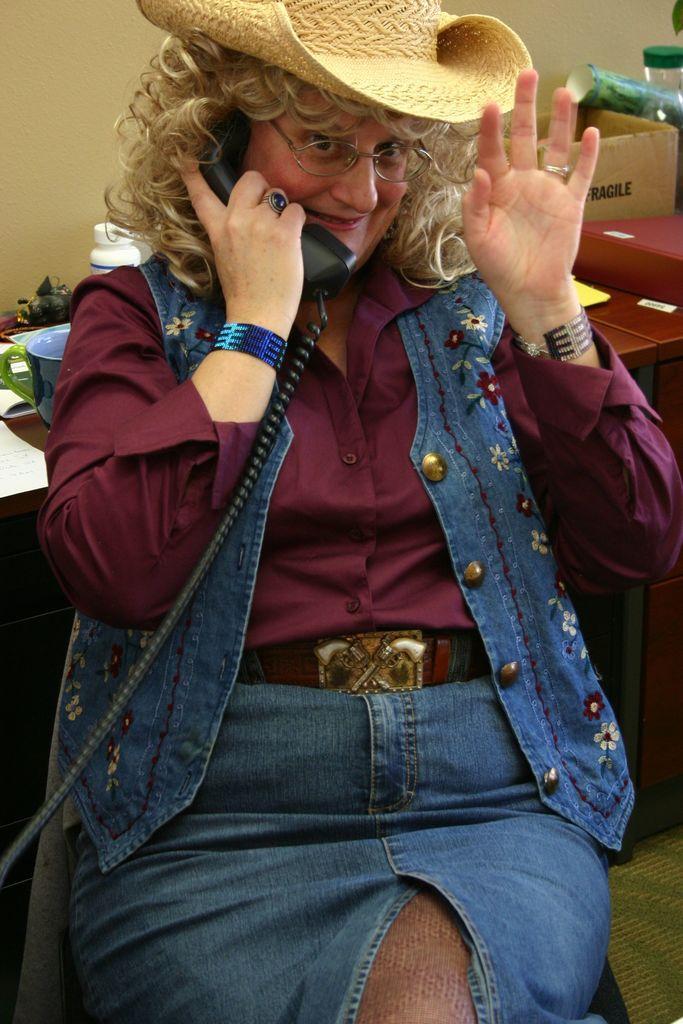How would you summarize this image in a sentence or two? Here we can see a woman talking on the phone. She has spectacles and she wore a hat. In the background we can see a table, papers, box, and wall. 